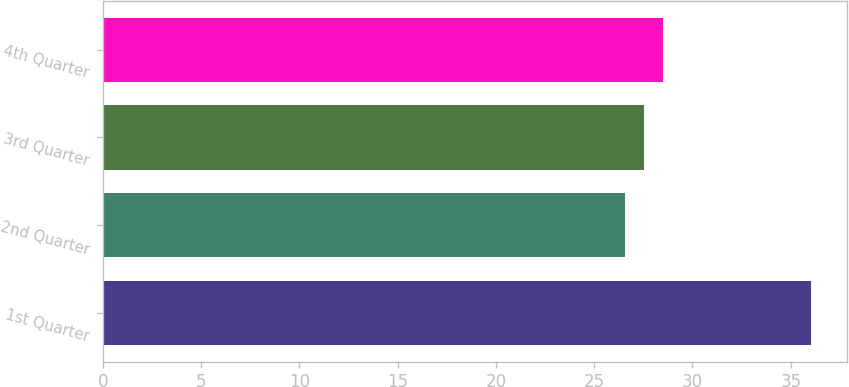<chart> <loc_0><loc_0><loc_500><loc_500><bar_chart><fcel>1st Quarter<fcel>2nd Quarter<fcel>3rd Quarter<fcel>4th Quarter<nl><fcel>36.04<fcel>26.56<fcel>27.53<fcel>28.48<nl></chart> 